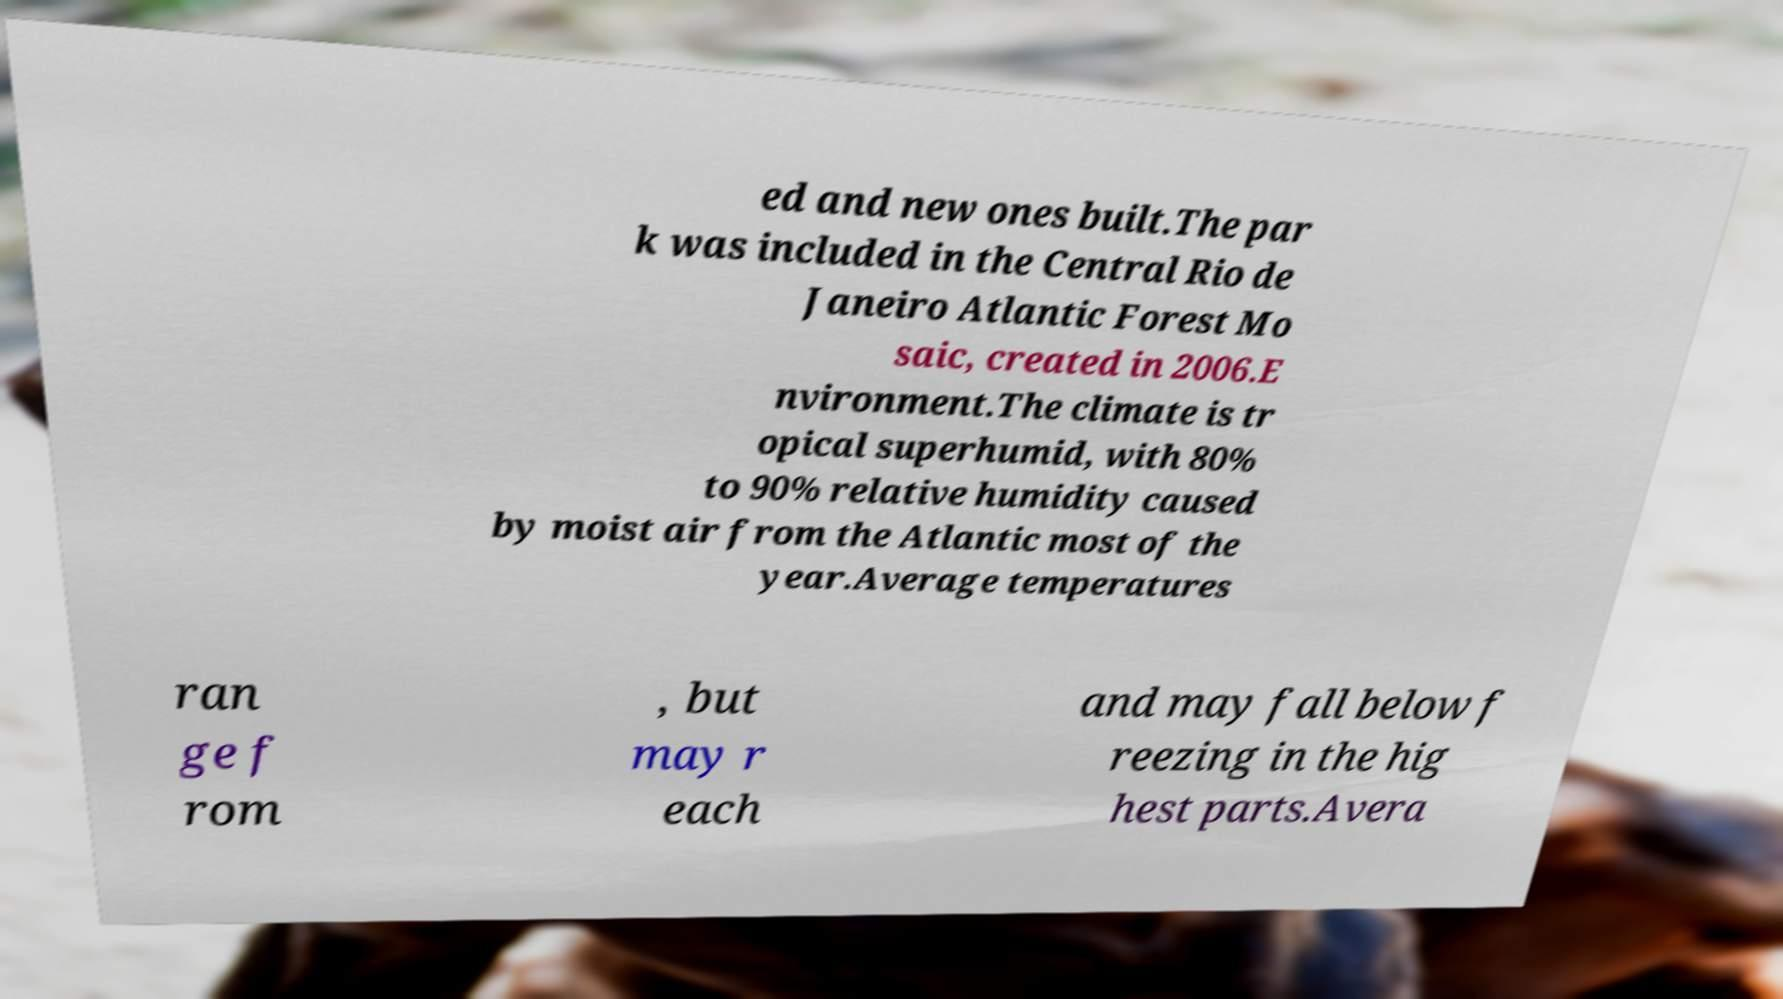Please read and relay the text visible in this image. What does it say? ed and new ones built.The par k was included in the Central Rio de Janeiro Atlantic Forest Mo saic, created in 2006.E nvironment.The climate is tr opical superhumid, with 80% to 90% relative humidity caused by moist air from the Atlantic most of the year.Average temperatures ran ge f rom , but may r each and may fall below f reezing in the hig hest parts.Avera 